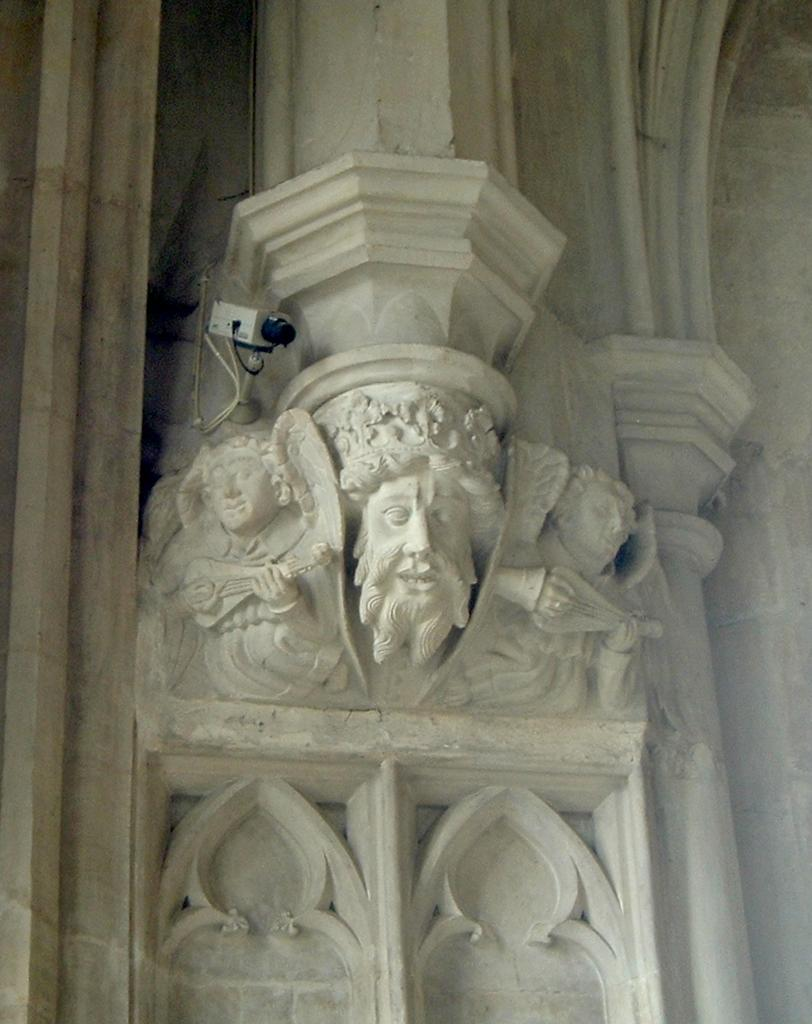What can be seen on the wall in the image? There are sculptures carved on the wall in the image, and there is also a camera on the wall. What might the camera be used for? The camera on the wall might be used for capturing images or recording videos. What type of van can be seen parked in front of the wall in the image? There is no van present in the image; it only features sculptures carved on the wall and a camera. 